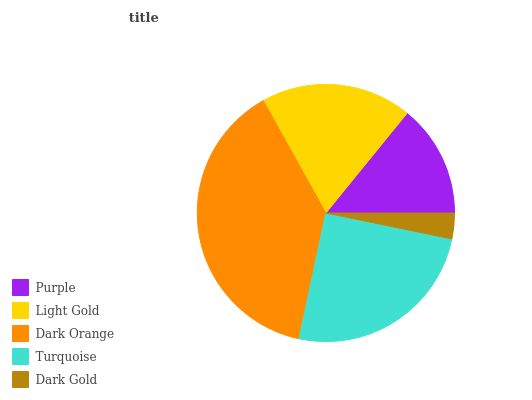Is Dark Gold the minimum?
Answer yes or no. Yes. Is Dark Orange the maximum?
Answer yes or no. Yes. Is Light Gold the minimum?
Answer yes or no. No. Is Light Gold the maximum?
Answer yes or no. No. Is Light Gold greater than Purple?
Answer yes or no. Yes. Is Purple less than Light Gold?
Answer yes or no. Yes. Is Purple greater than Light Gold?
Answer yes or no. No. Is Light Gold less than Purple?
Answer yes or no. No. Is Light Gold the high median?
Answer yes or no. Yes. Is Light Gold the low median?
Answer yes or no. Yes. Is Turquoise the high median?
Answer yes or no. No. Is Turquoise the low median?
Answer yes or no. No. 